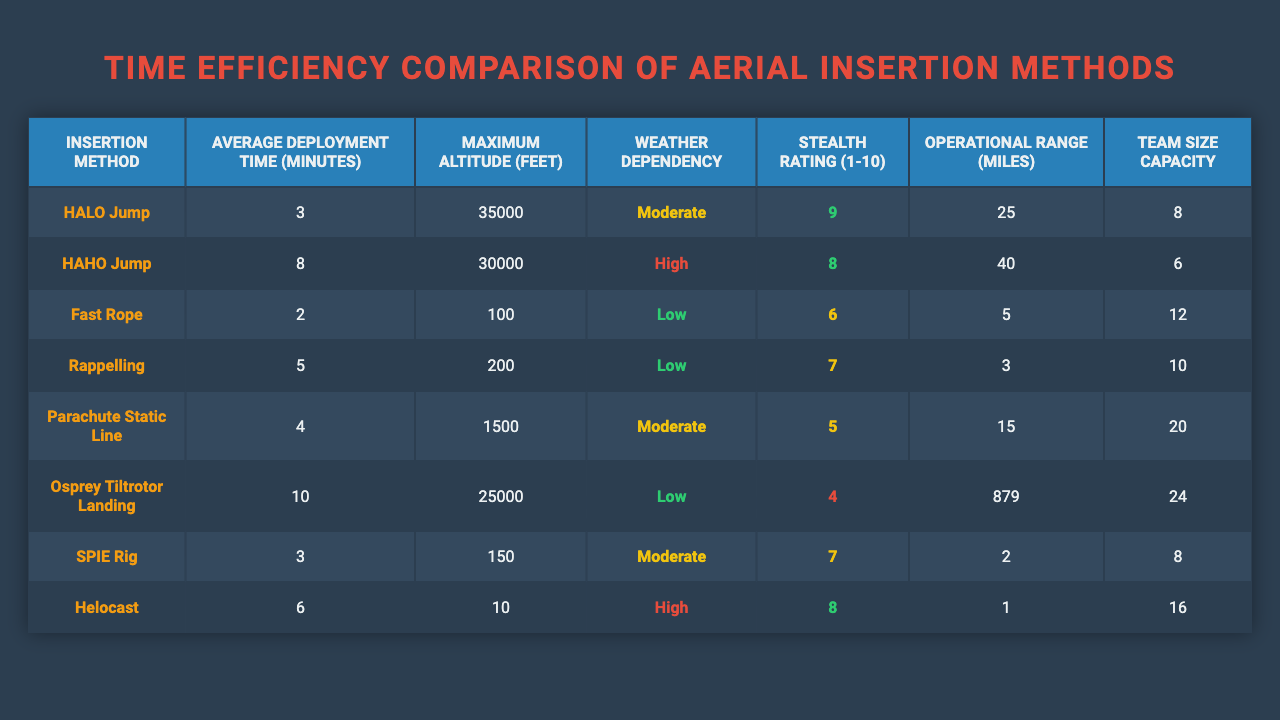What is the average deployment time for the HALO Jump? The table shows that the average deployment time for the HALO Jump is directly listed as 3 minutes.
Answer: 3 minutes Which insertion method has the highest stealth rating? By examining the stealth ratings in the table, the HALO Jump has the highest rating of 9.
Answer: HALO Jump How many insertion methods have an average deployment time of 5 minutes or less? The methods with 5 minutes or less are HALO Jump (3), Fast Rope (2), and SPIE Rig (3). This totals to three methods.
Answer: 3 What is the maximum altitude for the HAHO Jump? The table states that the maximum altitude for the HAHO Jump is 30,000 feet.
Answer: 30,000 feet Is the Osprey Tiltrotor Landing categorized as having low weather dependency? The table indicates that the Osprey Tiltrotor Landing has a weather dependency of "Low," confirming this fact is true.
Answer: Yes What is the difference in average deployment time between Fast Rope and Rappelling? Fast Rope has an average deployment time of 2 minutes, and Rappelling has 5 minutes. The difference is 5 - 2 = 3 minutes.
Answer: 3 minutes Which aerial insertion method has the operational range closest to 10 miles? Looking at the operational ranges, both Rappelling (3 miles) and Helocast (1 mile) are below it, but the method closest to 10 miles is Parachute Static Line at 15 miles.
Answer: Parachute Static Line What is the average height of all maximum altitudes across the insertion methods? The maximum altitudes are 35000, 30000, 100, 200, 1500, 25000, 150, and 10. Summing these gives 62970 feet, and dividing by 8 (the number of methods) results in an average height of approximately 7863.75 feet.
Answer: 7863.75 feet Which method allows for the largest team size capacity, and what is that number? The table shows that the Osprey Tiltrotor Landing allows for a team size capacity of 24, which is the largest among all methods.
Answer: Osprey Tiltrotor Landing, 24 How many methods have a stealth rating of 7 or higher? The stealth ratings of 9 (HALO Jump), 8 (HAHO Jump and Helocast), and 7 (Rappelling and SPIE Rig) indicate a total of five methods meeting this criterion.
Answer: 5 methods 